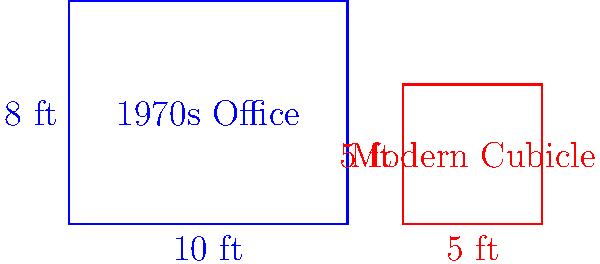In the diagram above, a traditional office from the 1970s is compared to a modern office cubicle. The 1970s office measures 10 feet by 8 feet, while the modern cubicle is 5 feet by 5 feet. What is the difference in square footage between the 1970s office and the modern cubicle? Express your answer as a percentage of the 1970s office area, rounded to the nearest whole percent. To solve this problem, let's follow these steps:

1. Calculate the area of the 1970s office:
   $A_{1970} = 10 \text{ ft} \times 8 \text{ ft} = 80 \text{ sq ft}$

2. Calculate the area of the modern cubicle:
   $A_{\text{modern}} = 5 \text{ ft} \times 5 \text{ ft} = 25 \text{ sq ft}$

3. Find the difference in square footage:
   $\text{Difference} = A_{1970} - A_{\text{modern}} = 80 \text{ sq ft} - 25 \text{ sq ft} = 55 \text{ sq ft}$

4. Express the difference as a percentage of the 1970s office area:
   $$\text{Percentage} = \frac{\text{Difference}}{A_{1970}} \times 100\% = \frac{55 \text{ sq ft}}{80 \text{ sq ft}} \times 100\% = 68.75\%$$

5. Round to the nearest whole percent:
   $68.75\% \approx 69\%$

Therefore, the difference in square footage between the 1970s office and the modern cubicle is approximately 69% of the 1970s office area.
Answer: 69% 